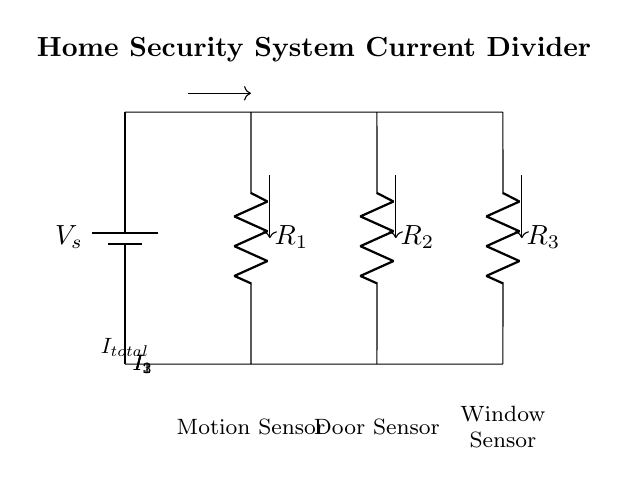What is the total current entering the circuit? The total current entering the circuit, labeled as I total, represents the total current supplied by the voltage source to all parallel branches. It is the sum of the individual currents flowing through each branch.
Answer: I total What type of circuit is depicted in the diagram? The circuit depicted is a current divider configuration, which is characterized by having multiple branches running in parallel, allowing the total current to be divided among the branches based on their resistances.
Answer: Current divider Which sensor is associated with resistor R one? Resistor R one is connected to the motion sensor, as indicated by the labeling below this component on the circuit diagram.
Answer: Motion sensor How many sensors are shown in the circuit? The circuit displays three sensors, one for each resistor in the parallel configuration, which includes the motion sensor, door sensor, and window sensor.
Answer: Three What determines the distribution of current among the branches? The distribution of current among the branches is determined by the resistances of R one, R two, and R three; higher resistance in a branch results in lower current through that branch, following the principles of a current divider.
Answer: Resistances What is the relationship between the currents I one, I two, and I three? The relationship follows the formula I total equals I one plus I two plus I three, where the individual currents are inversely related to their respective resistances; this is known as the current divider rule.
Answer: I total equals I one plus I two plus I three 